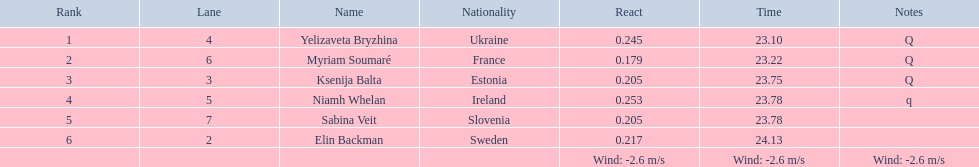Can you provide the names of all participants? Yelizaveta Bryzhina, Myriam Soumaré, Ksenija Balta, Niamh Whelan, Sabina Veit, Elin Backman. What were their end times? 23.10, 23.22, 23.75, 23.78, 23.78, 24.13. Also, what was ellen backman's completion time? 24.13. 